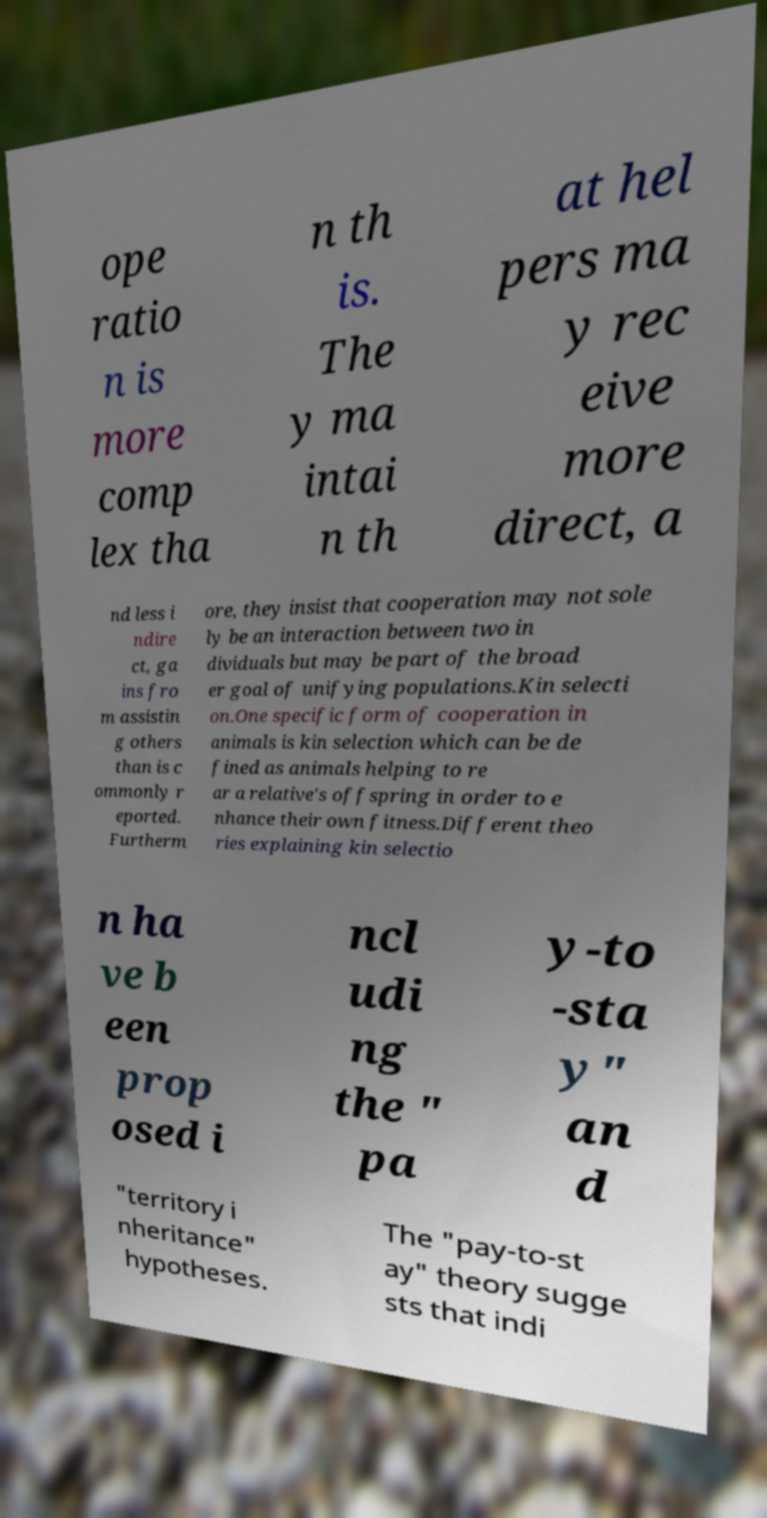Please read and relay the text visible in this image. What does it say? ope ratio n is more comp lex tha n th is. The y ma intai n th at hel pers ma y rec eive more direct, a nd less i ndire ct, ga ins fro m assistin g others than is c ommonly r eported. Furtherm ore, they insist that cooperation may not sole ly be an interaction between two in dividuals but may be part of the broad er goal of unifying populations.Kin selecti on.One specific form of cooperation in animals is kin selection which can be de fined as animals helping to re ar a relative's offspring in order to e nhance their own fitness.Different theo ries explaining kin selectio n ha ve b een prop osed i ncl udi ng the " pa y-to -sta y" an d "territory i nheritance" hypotheses. The "pay-to-st ay" theory sugge sts that indi 